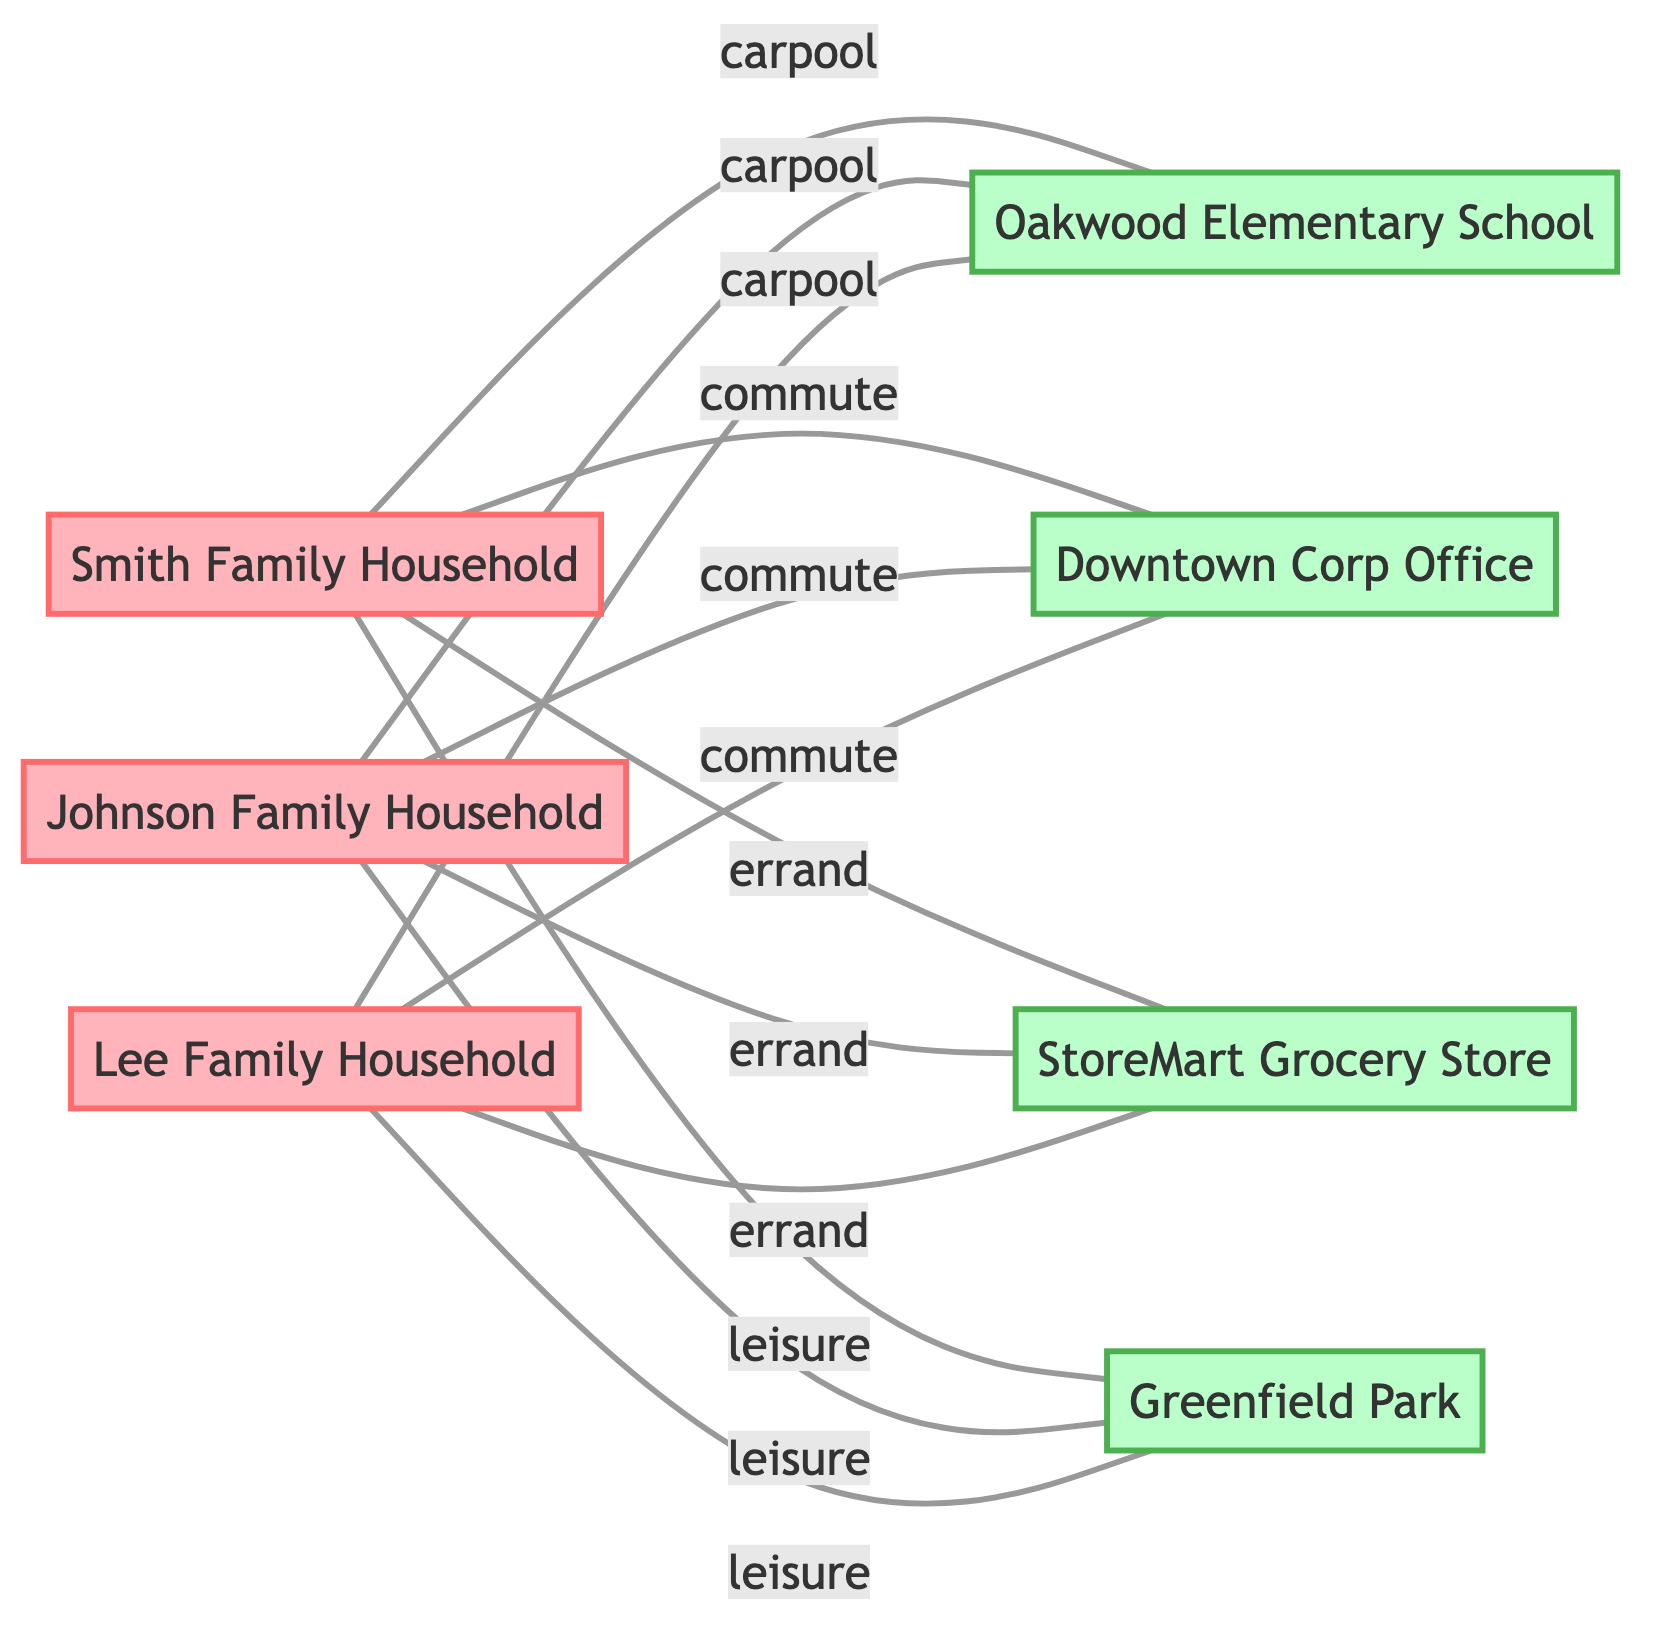What is the total number of households represented in the diagram? The diagram includes three households: Smith Family Household, Johnson Family Household, and Lee Family Household. Counting these nodes gives a total of three households.
Answer: 3 Which destination is connected to all three households for carpooling? The Oakwood Elementary School is the only destination that shows connections (edges) from all three households (Smith, Johnson, Lee) for carpooling. This can be identified by looking for the label "carpool" in the edges connected to the school node.
Answer: Oakwood Elementary School How many different types of trips are represented in the diagram? There are four types of trips represented: carpool, commute, errand, and leisure. Each type of trip is linked to connections between households and destinations. This can be seen by examining the labels on the edges.
Answer: 4 Which household connects to the Downtown Corp Office? The edges show that all three households (Smith, Johnson, Lee) connect to the Downtown Corp Office. The question requires identifying edges leading from each household to this office node.
Answer: Smith Family Household, Johnson Family Household, Lee Family Household Which destination has the label associated with leisure activities? Greenfield Park is designated as the leisure destination, indicated by the edges labeled with "leisure" connecting from all three households. To answer, one needs to locate the node with the specific label associated with leisure.
Answer: Greenfield Park Which household has the highest number of connections? Since all three households (Smith, Johnson, Lee) have identical connections—each connecting to three destinations for carpooling, commuting, errands, and leisure—the maximum connections count is the same for each household. Therefore, they all have the same highest number of connections.
Answer: Smith Family Household, Johnson Family Household, Lee Family Household Are there any households that connect to StoreMart Grocery Store? Yes, all three households (Smith, Johnson, Lee) connect to the StoreMart Grocery Store, as indicated in the edges which show the label "errand" for connections from each household to this grocery destination.
Answer: Smith Family Household, Johnson Family Household, Lee Family Household What edge label connects the households to Oakswood Elementary School? The edge label connecting each of the households to Oakwood Elementary School is "carpool." This can be identified from the edges shown in the diagram.
Answer: carpool 